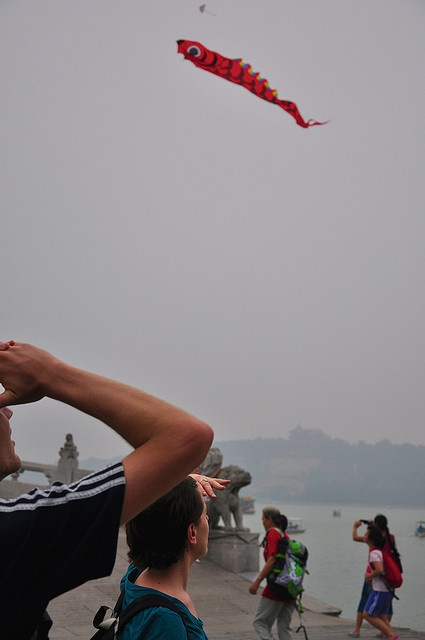Describe the objects in this image and their specific colors. I can see people in darkgray, black, maroon, and gray tones, people in darkgray, black, maroon, gray, and brown tones, people in darkgray, black, gray, and maroon tones, kite in darkgray, brown, and maroon tones, and people in darkgray, black, maroon, navy, and gray tones in this image. 